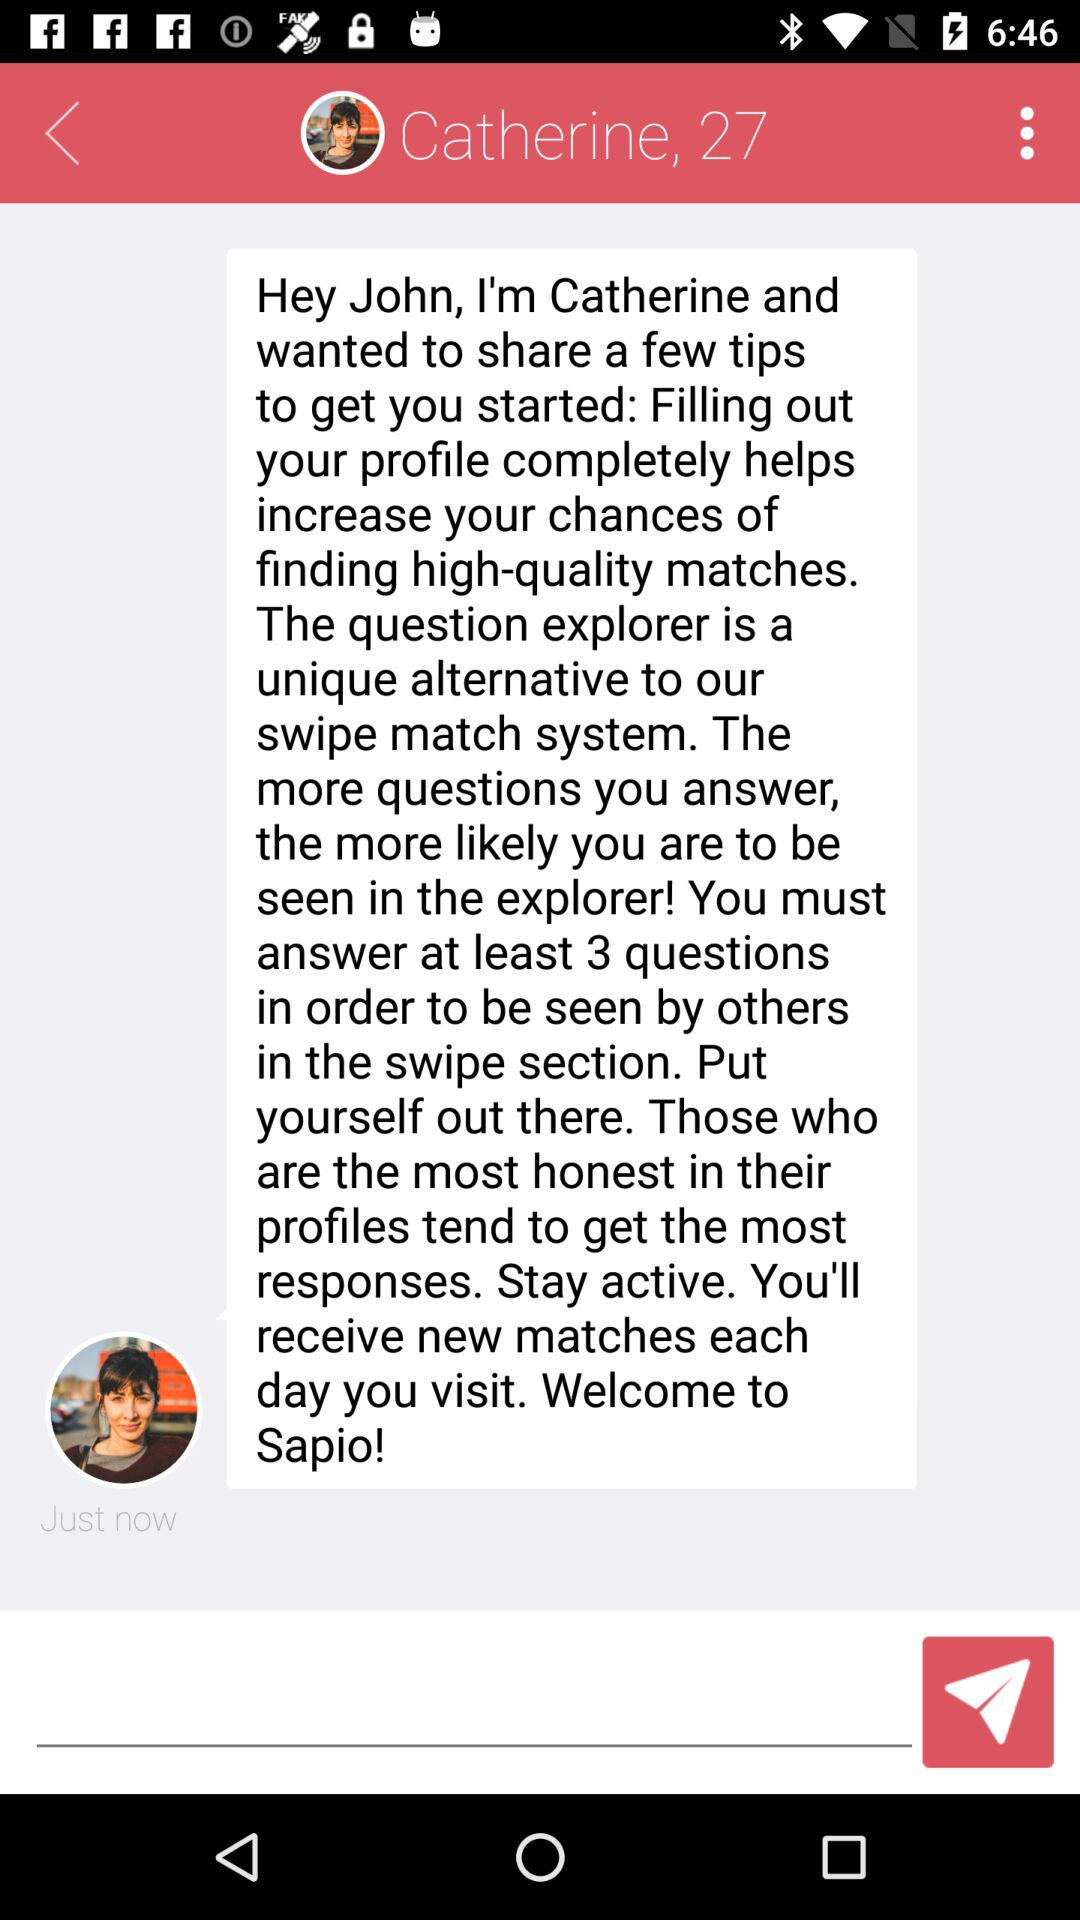What is the name? The name is Catherine and John. 